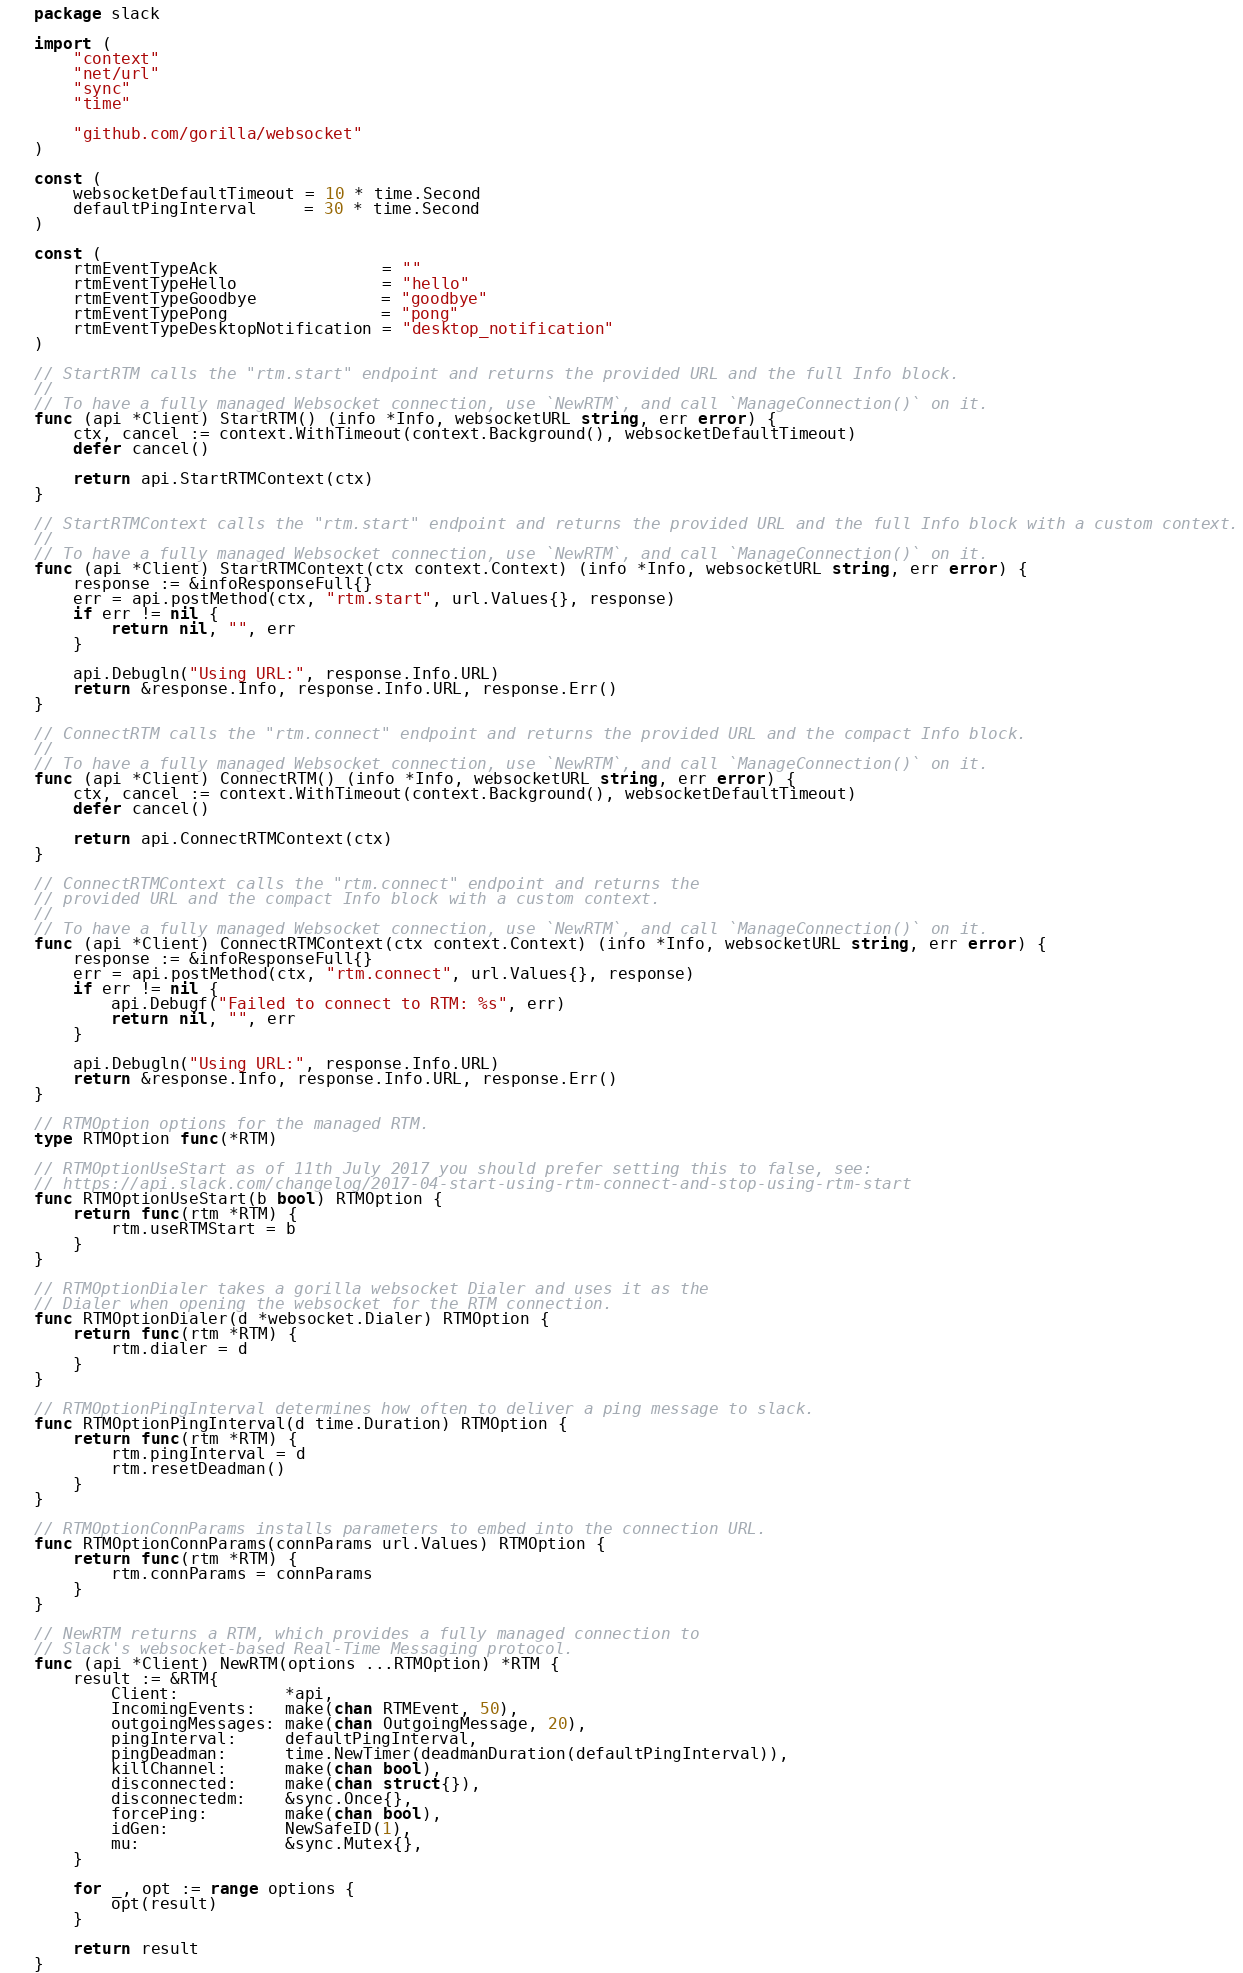Convert code to text. <code><loc_0><loc_0><loc_500><loc_500><_Go_>package slack

import (
	"context"
	"net/url"
	"sync"
	"time"

	"github.com/gorilla/websocket"
)

const (
	websocketDefaultTimeout = 10 * time.Second
	defaultPingInterval     = 30 * time.Second
)

const (
	rtmEventTypeAck                 = ""
	rtmEventTypeHello               = "hello"
	rtmEventTypeGoodbye             = "goodbye"
	rtmEventTypePong                = "pong"
	rtmEventTypeDesktopNotification = "desktop_notification"
)

// StartRTM calls the "rtm.start" endpoint and returns the provided URL and the full Info block.
//
// To have a fully managed Websocket connection, use `NewRTM`, and call `ManageConnection()` on it.
func (api *Client) StartRTM() (info *Info, websocketURL string, err error) {
	ctx, cancel := context.WithTimeout(context.Background(), websocketDefaultTimeout)
	defer cancel()

	return api.StartRTMContext(ctx)
}

// StartRTMContext calls the "rtm.start" endpoint and returns the provided URL and the full Info block with a custom context.
//
// To have a fully managed Websocket connection, use `NewRTM`, and call `ManageConnection()` on it.
func (api *Client) StartRTMContext(ctx context.Context) (info *Info, websocketURL string, err error) {
	response := &infoResponseFull{}
	err = api.postMethod(ctx, "rtm.start", url.Values{}, response)
	if err != nil {
		return nil, "", err
	}

	api.Debugln("Using URL:", response.Info.URL)
	return &response.Info, response.Info.URL, response.Err()
}

// ConnectRTM calls the "rtm.connect" endpoint and returns the provided URL and the compact Info block.
//
// To have a fully managed Websocket connection, use `NewRTM`, and call `ManageConnection()` on it.
func (api *Client) ConnectRTM() (info *Info, websocketURL string, err error) {
	ctx, cancel := context.WithTimeout(context.Background(), websocketDefaultTimeout)
	defer cancel()

	return api.ConnectRTMContext(ctx)
}

// ConnectRTMContext calls the "rtm.connect" endpoint and returns the
// provided URL and the compact Info block with a custom context.
//
// To have a fully managed Websocket connection, use `NewRTM`, and call `ManageConnection()` on it.
func (api *Client) ConnectRTMContext(ctx context.Context) (info *Info, websocketURL string, err error) {
	response := &infoResponseFull{}
	err = api.postMethod(ctx, "rtm.connect", url.Values{}, response)
	if err != nil {
		api.Debugf("Failed to connect to RTM: %s", err)
		return nil, "", err
	}

	api.Debugln("Using URL:", response.Info.URL)
	return &response.Info, response.Info.URL, response.Err()
}

// RTMOption options for the managed RTM.
type RTMOption func(*RTM)

// RTMOptionUseStart as of 11th July 2017 you should prefer setting this to false, see:
// https://api.slack.com/changelog/2017-04-start-using-rtm-connect-and-stop-using-rtm-start
func RTMOptionUseStart(b bool) RTMOption {
	return func(rtm *RTM) {
		rtm.useRTMStart = b
	}
}

// RTMOptionDialer takes a gorilla websocket Dialer and uses it as the
// Dialer when opening the websocket for the RTM connection.
func RTMOptionDialer(d *websocket.Dialer) RTMOption {
	return func(rtm *RTM) {
		rtm.dialer = d
	}
}

// RTMOptionPingInterval determines how often to deliver a ping message to slack.
func RTMOptionPingInterval(d time.Duration) RTMOption {
	return func(rtm *RTM) {
		rtm.pingInterval = d
		rtm.resetDeadman()
	}
}

// RTMOptionConnParams installs parameters to embed into the connection URL.
func RTMOptionConnParams(connParams url.Values) RTMOption {
	return func(rtm *RTM) {
		rtm.connParams = connParams
	}
}

// NewRTM returns a RTM, which provides a fully managed connection to
// Slack's websocket-based Real-Time Messaging protocol.
func (api *Client) NewRTM(options ...RTMOption) *RTM {
	result := &RTM{
		Client:           *api,
		IncomingEvents:   make(chan RTMEvent, 50),
		outgoingMessages: make(chan OutgoingMessage, 20),
		pingInterval:     defaultPingInterval,
		pingDeadman:      time.NewTimer(deadmanDuration(defaultPingInterval)),
		killChannel:      make(chan bool),
		disconnected:     make(chan struct{}),
		disconnectedm:    &sync.Once{},
		forcePing:        make(chan bool),
		idGen:            NewSafeID(1),
		mu:               &sync.Mutex{},
	}

	for _, opt := range options {
		opt(result)
	}

	return result
}
</code> 